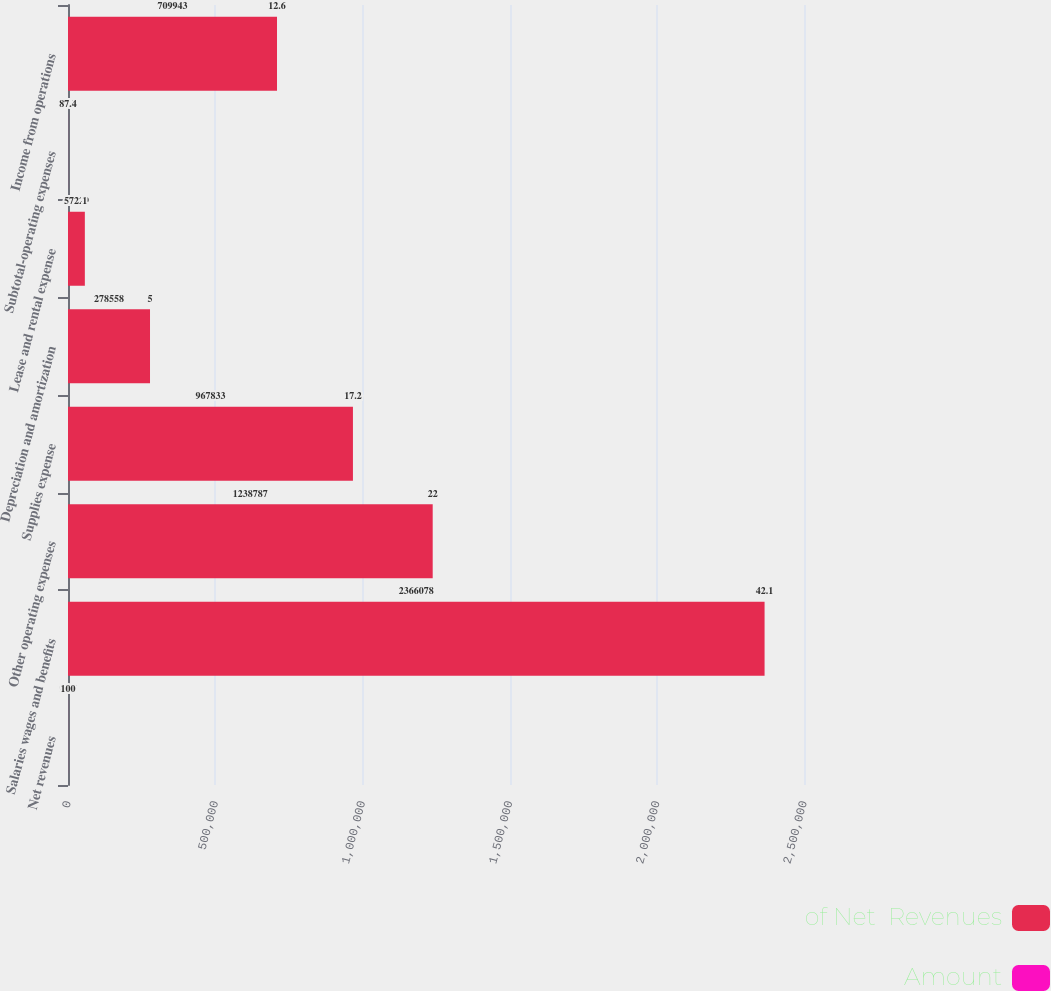Convert chart. <chart><loc_0><loc_0><loc_500><loc_500><stacked_bar_chart><ecel><fcel>Net revenues<fcel>Salaries wages and benefits<fcel>Other operating expenses<fcel>Supplies expense<fcel>Depreciation and amortization<fcel>Lease and rental expense<fcel>Subtotal-operating expenses<fcel>Income from operations<nl><fcel>of Net  Revenues<fcel>93.7<fcel>2.36608e+06<fcel>1.23879e+06<fcel>967833<fcel>278558<fcel>57229<fcel>93.7<fcel>709943<nl><fcel>Amount<fcel>100<fcel>42.1<fcel>22<fcel>17.2<fcel>5<fcel>1<fcel>87.4<fcel>12.6<nl></chart> 